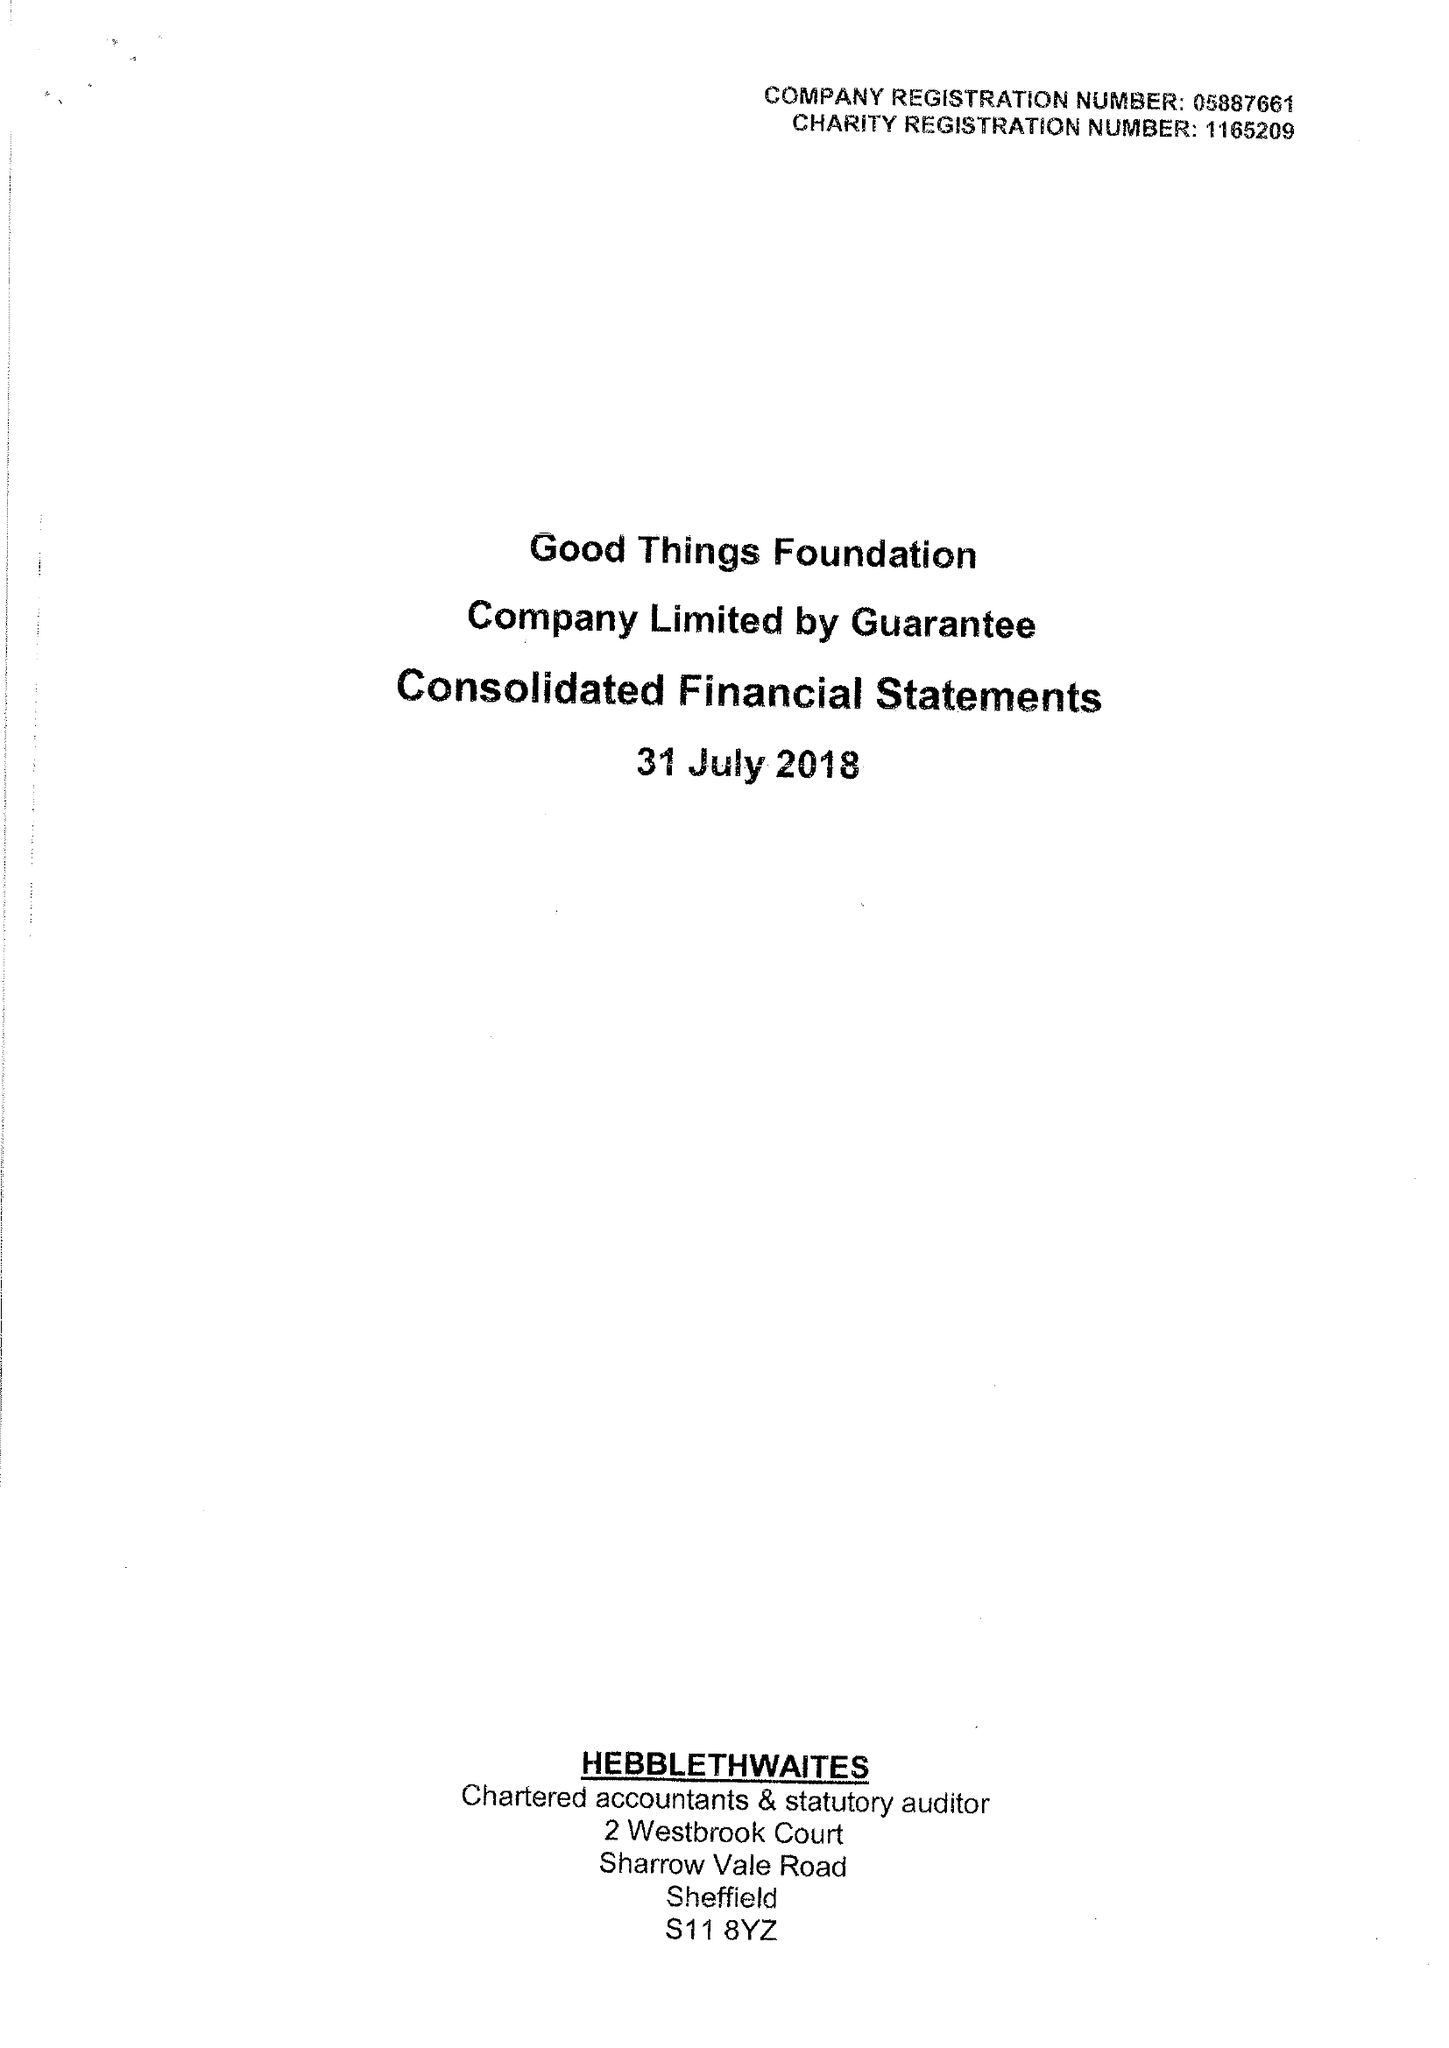What is the value for the address__postcode?
Answer the question using a single word or phrase. S1 2ET 